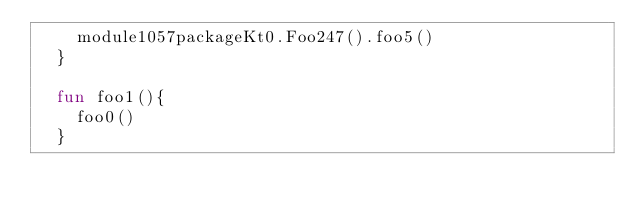Convert code to text. <code><loc_0><loc_0><loc_500><loc_500><_Kotlin_>    module1057packageKt0.Foo247().foo5()
  }

  fun foo1(){
    foo0()
  }
</code> 